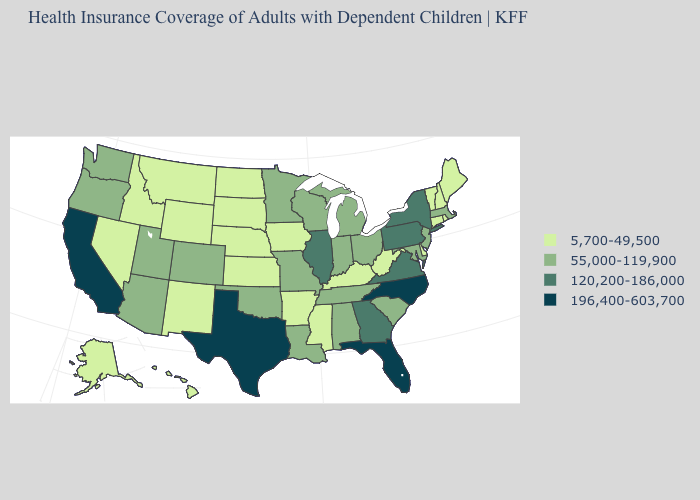Does North Carolina have the highest value in the USA?
Write a very short answer. Yes. What is the value of Pennsylvania?
Keep it brief. 120,200-186,000. Name the states that have a value in the range 196,400-603,700?
Quick response, please. California, Florida, North Carolina, Texas. Among the states that border Connecticut , which have the lowest value?
Concise answer only. Rhode Island. What is the value of Maine?
Give a very brief answer. 5,700-49,500. Which states have the highest value in the USA?
Write a very short answer. California, Florida, North Carolina, Texas. Does Washington have the lowest value in the USA?
Give a very brief answer. No. Does the first symbol in the legend represent the smallest category?
Concise answer only. Yes. Name the states that have a value in the range 120,200-186,000?
Write a very short answer. Georgia, Illinois, New York, Pennsylvania, Virginia. How many symbols are there in the legend?
Keep it brief. 4. Does Ohio have the lowest value in the MidWest?
Short answer required. No. How many symbols are there in the legend?
Write a very short answer. 4. What is the value of Maryland?
Concise answer only. 55,000-119,900. What is the lowest value in the South?
Answer briefly. 5,700-49,500. Name the states that have a value in the range 196,400-603,700?
Concise answer only. California, Florida, North Carolina, Texas. 